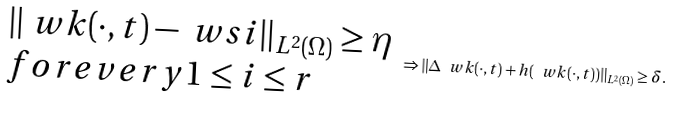Convert formula to latex. <formula><loc_0><loc_0><loc_500><loc_500>\begin{array} { l } \| \ w k ( \cdot , t ) - \ w s i \| _ { L ^ { 2 } ( \Omega ) } \geq \eta \\ f o r e v e r y 1 \leq i \leq r \end{array} \Rightarrow \| \Delta \ w k ( \cdot , t ) + h ( \ w k ( \cdot , t ) ) \| _ { L ^ { 2 } ( \Omega ) } \geq \delta .</formula> 